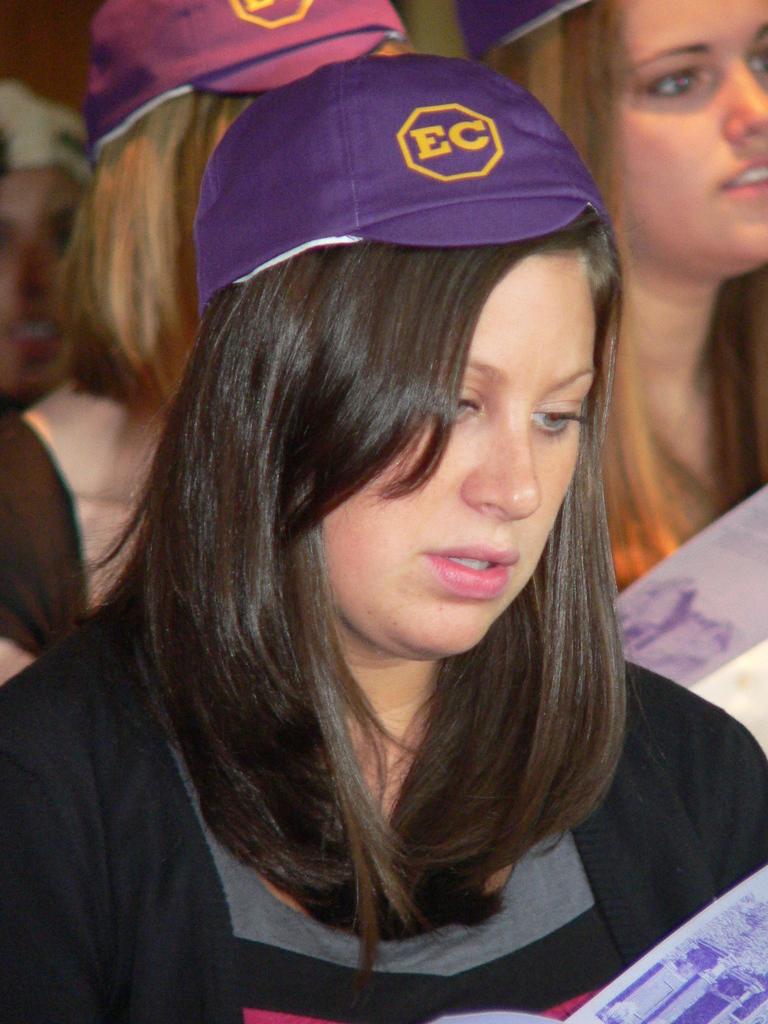What does her hat say?
Offer a very short reply. Ec. What color are the letters on her hat?
Offer a terse response. Yellow. 